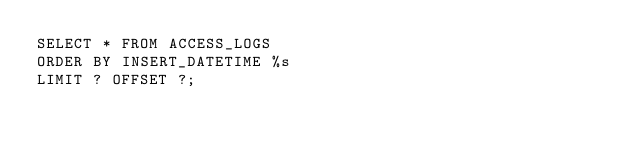<code> <loc_0><loc_0><loc_500><loc_500><_SQL_>SELECT * FROM ACCESS_LOGS
ORDER BY INSERT_DATETIME %s
LIMIT ? OFFSET ?;
</code> 